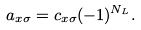<formula> <loc_0><loc_0><loc_500><loc_500>a _ { x \sigma } = c _ { x \sigma } ( - 1 ) ^ { N _ { L } } .</formula> 